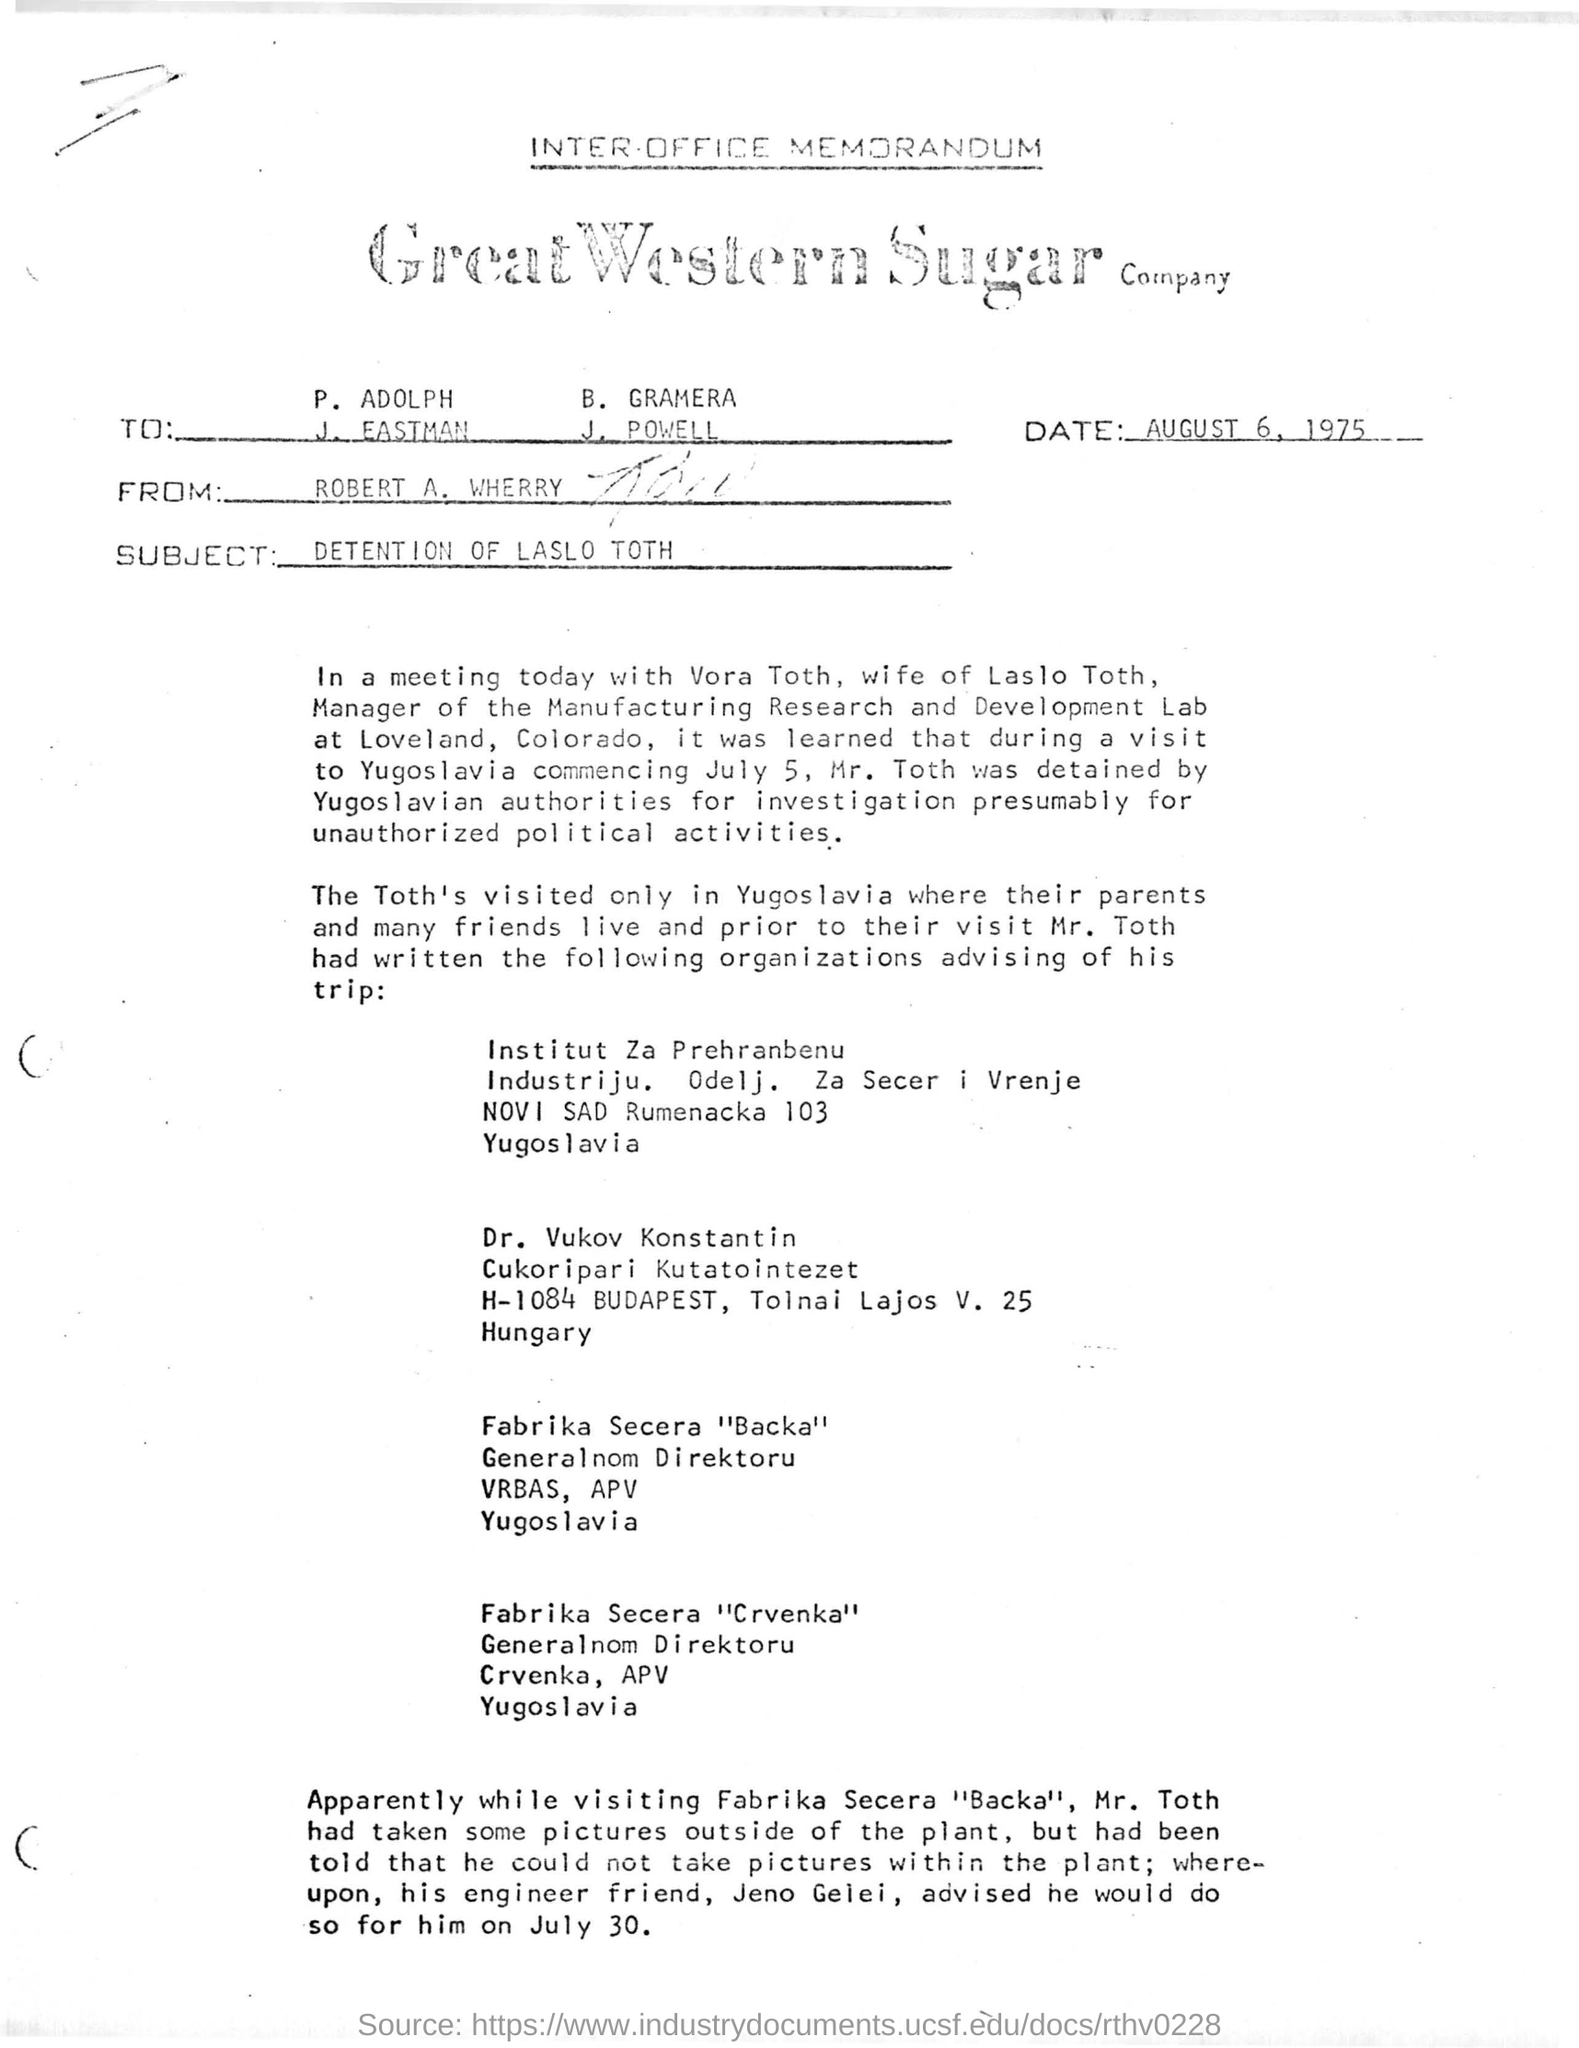What is written in top of the document ?
Provide a succinct answer. INTER-OFFICE MEMORANDUM. What is the Company Name ?
Make the answer very short. GREAT WESTERN SUGAR. What is the date mentioned in the top of the document ?
Offer a very short reply. AUGUST 6, 1975. Who sent this ?
Your answer should be very brief. ROBERT A. WHERRY. What is the Subject Line of the document ?
Make the answer very short. DETENTION OF LASLO TOTH. 